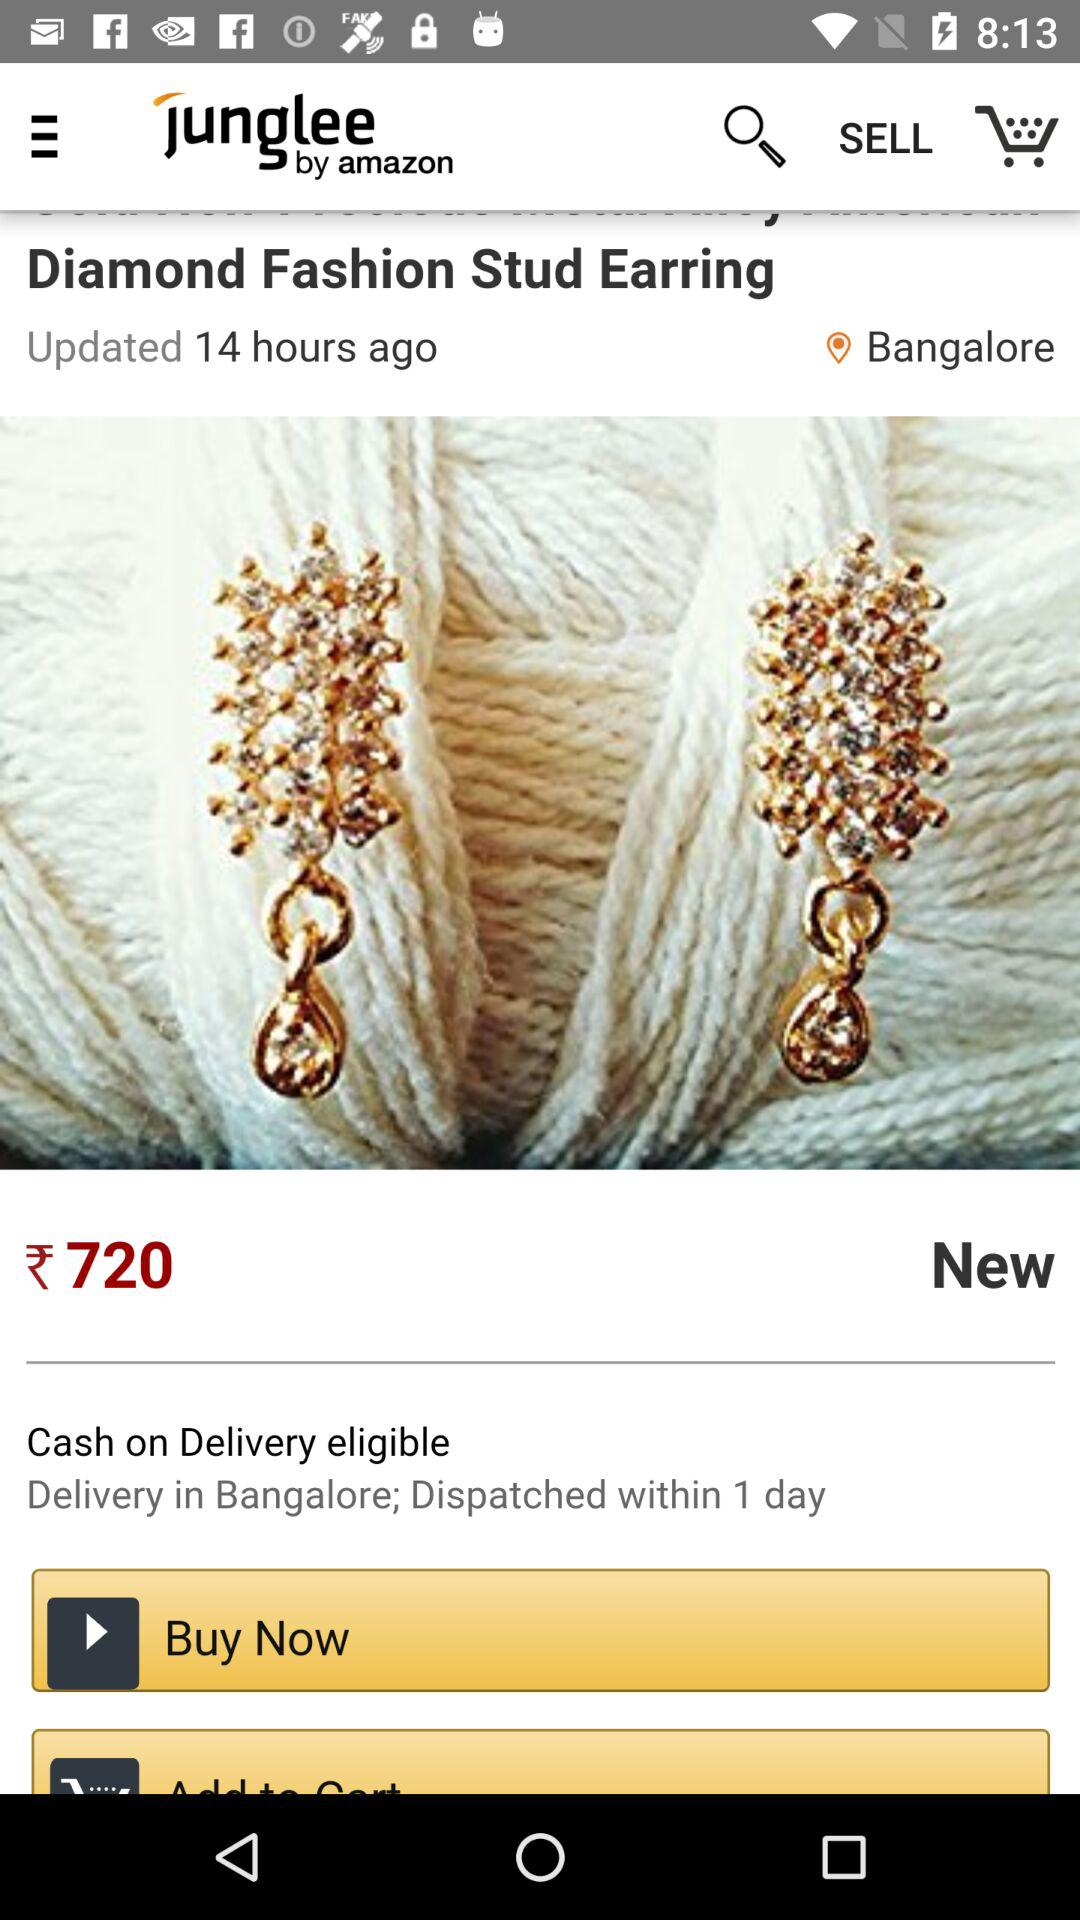What is the name of the application? The name of the application is "Junglee by Amazon". 